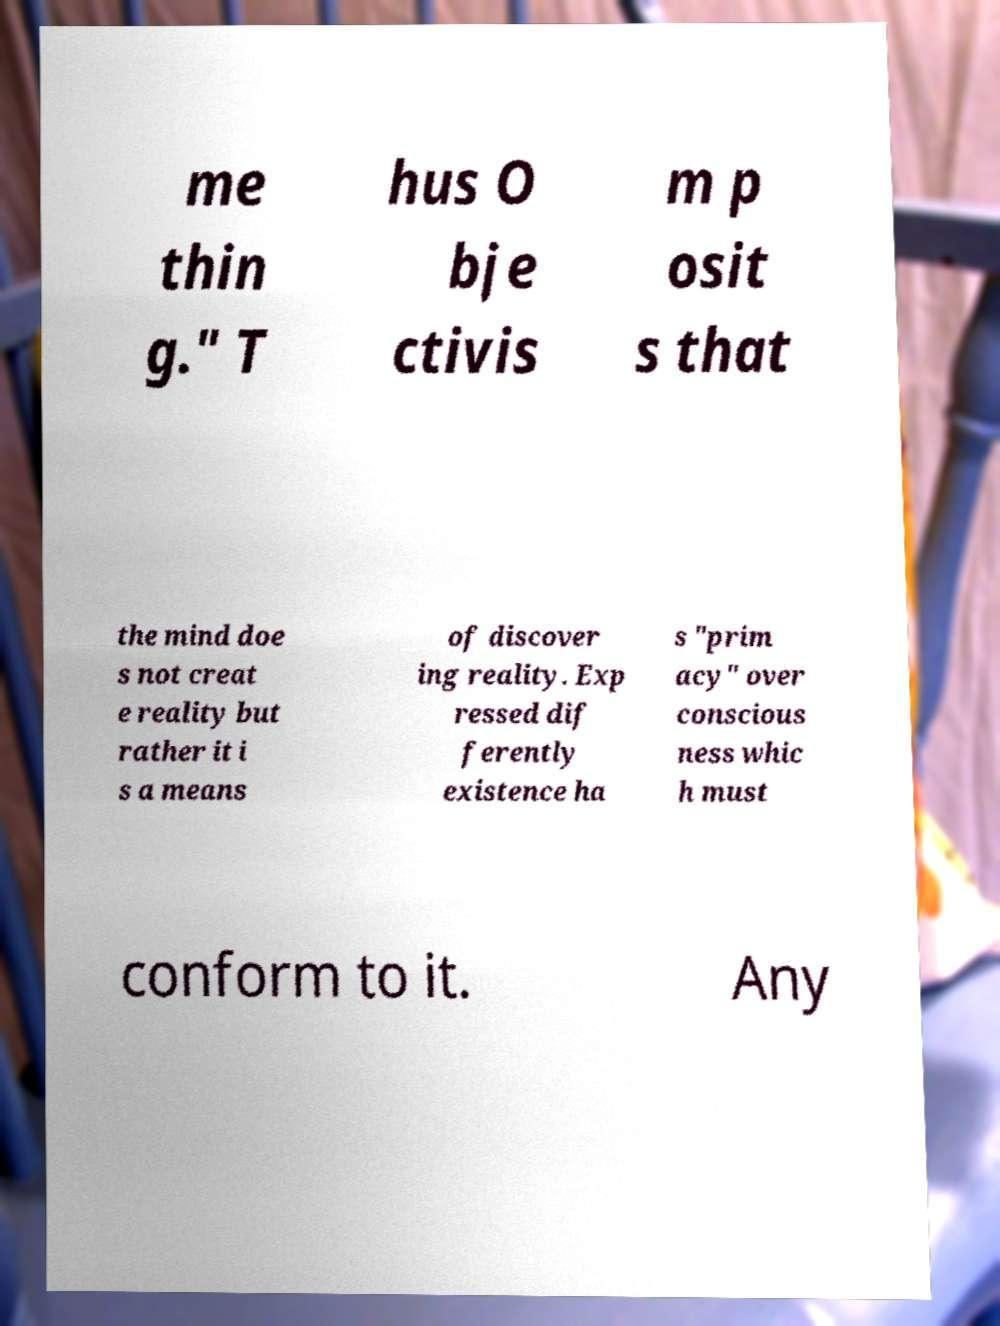There's text embedded in this image that I need extracted. Can you transcribe it verbatim? me thin g." T hus O bje ctivis m p osit s that the mind doe s not creat e reality but rather it i s a means of discover ing reality. Exp ressed dif ferently existence ha s "prim acy" over conscious ness whic h must conform to it. Any 